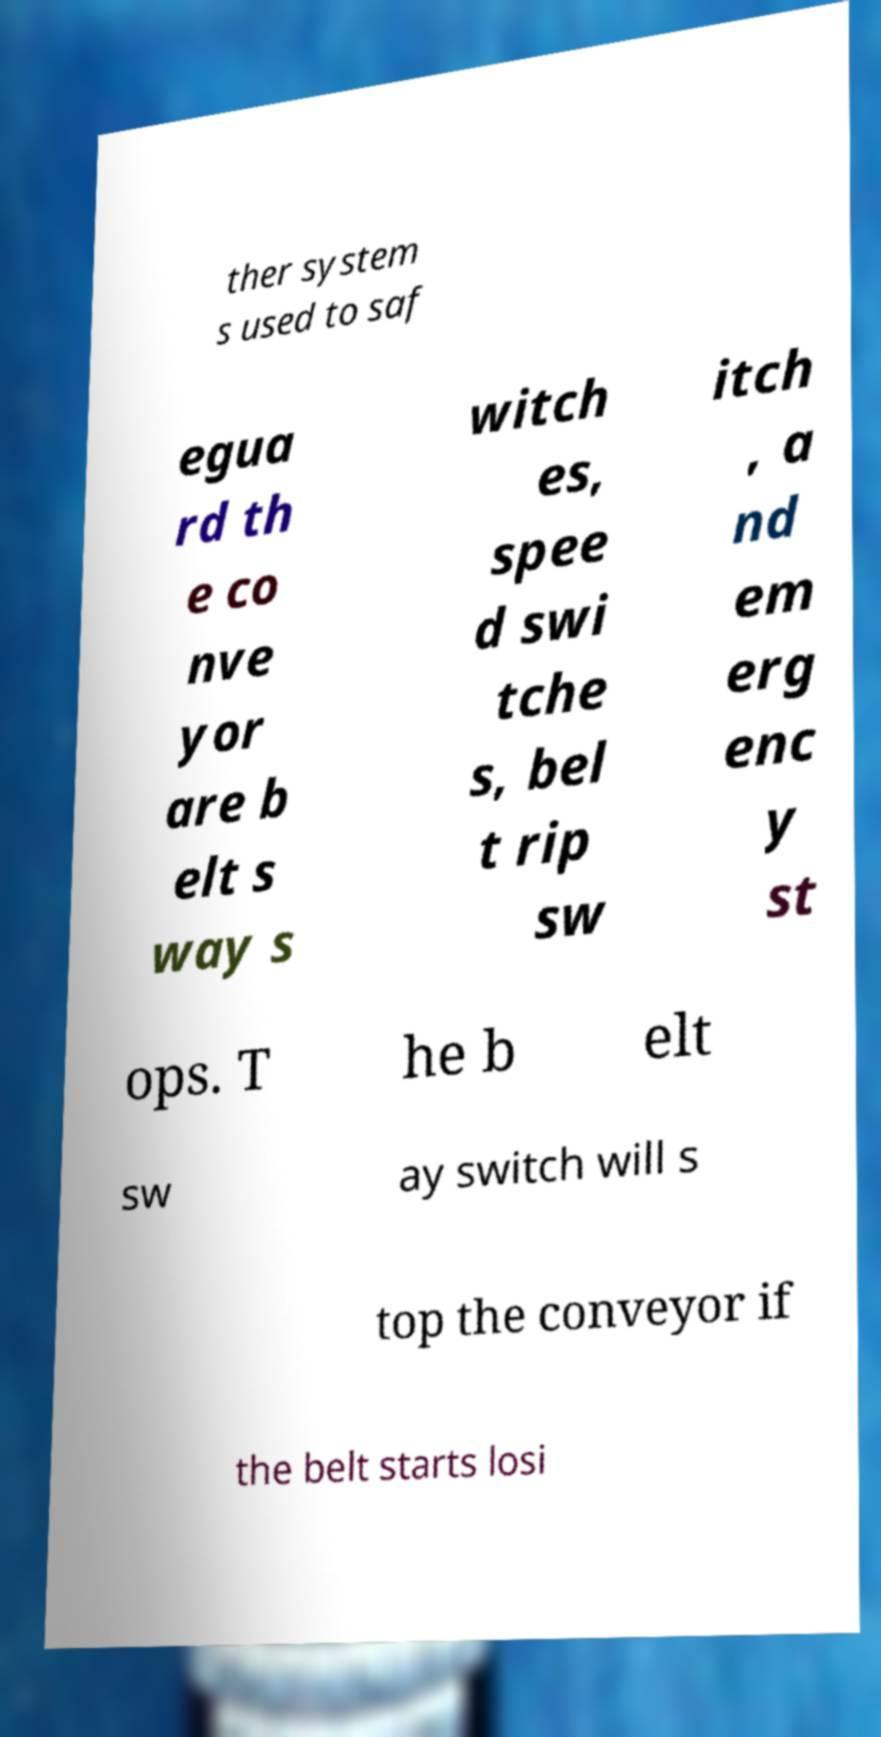For documentation purposes, I need the text within this image transcribed. Could you provide that? ther system s used to saf egua rd th e co nve yor are b elt s way s witch es, spee d swi tche s, bel t rip sw itch , a nd em erg enc y st ops. T he b elt sw ay switch will s top the conveyor if the belt starts losi 